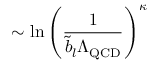Convert formula to latex. <formula><loc_0><loc_0><loc_500><loc_500>\sim \ln \left ( \frac { 1 } { \tilde { b } _ { l } \Lambda _ { Q C D } } \right ) ^ { \kappa }</formula> 